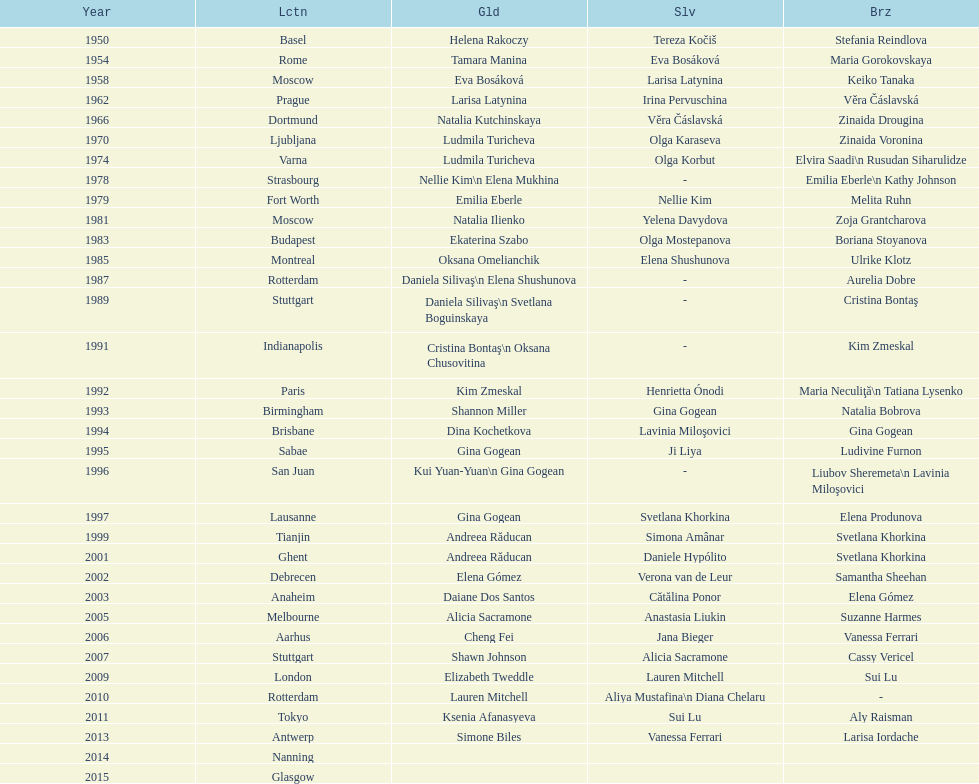What is the duration between the instances when the championship took place in moscow? 23 years. 